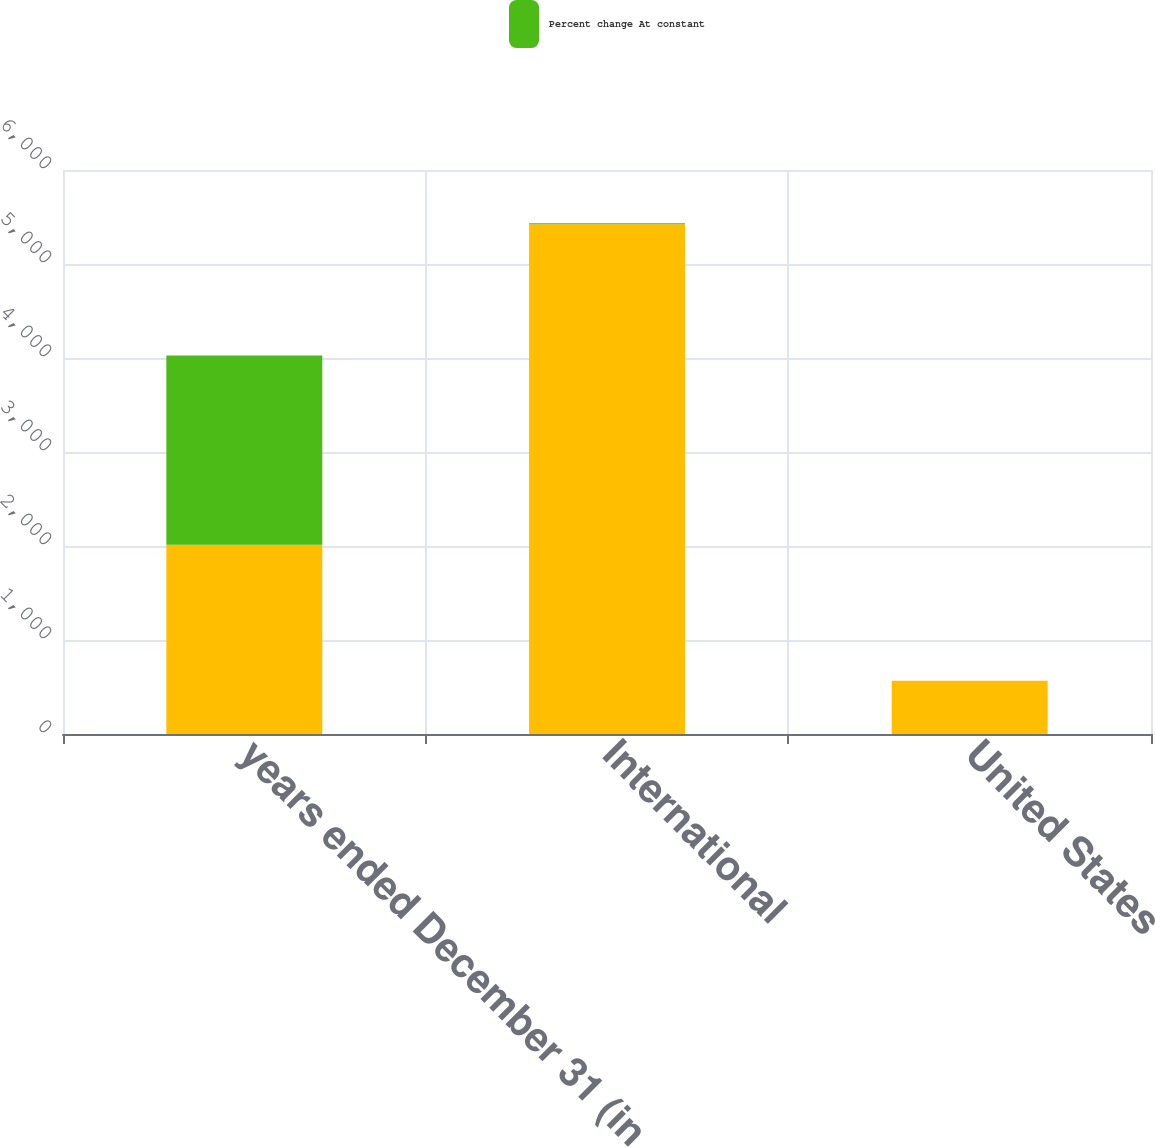Convert chart. <chart><loc_0><loc_0><loc_500><loc_500><stacked_bar_chart><ecel><fcel>years ended December 31 (in<fcel>International<fcel>United States<nl><fcel>nan<fcel>2013<fcel>5423<fcel>566<nl><fcel>Percent change At constant<fcel>2013<fcel>11<fcel>1<nl></chart> 